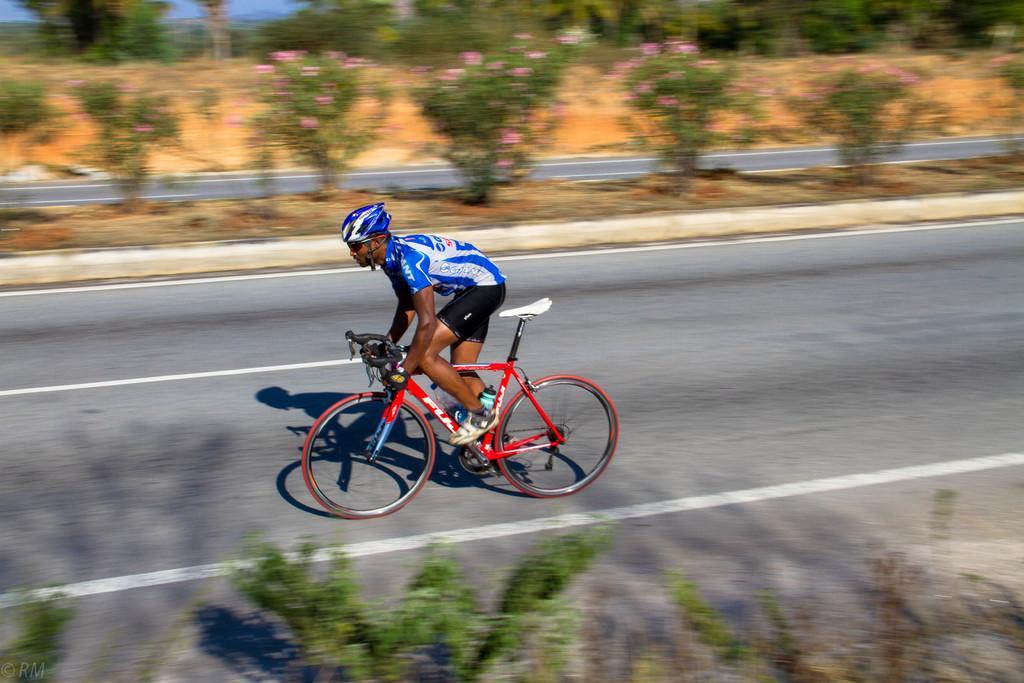How would you summarize this image in a sentence or two? In the image there is a person riding cycle on a road and beside the road there are many plants. 